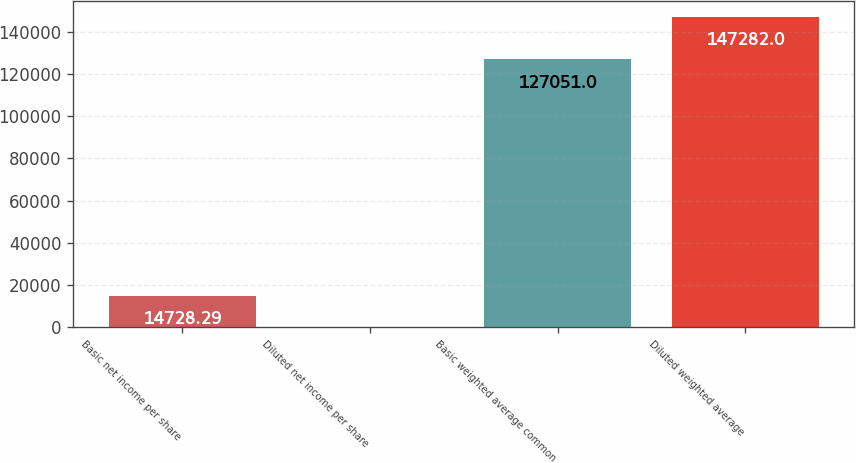Convert chart to OTSL. <chart><loc_0><loc_0><loc_500><loc_500><bar_chart><fcel>Basic net income per share<fcel>Diluted net income per share<fcel>Basic weighted average common<fcel>Diluted weighted average<nl><fcel>14728.3<fcel>0.1<fcel>127051<fcel>147282<nl></chart> 